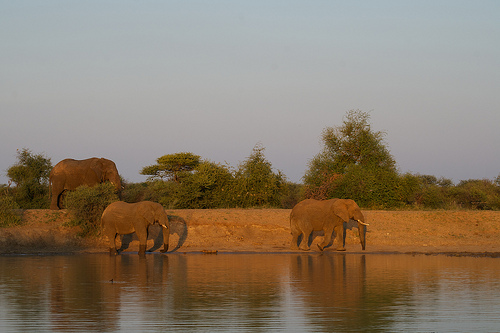Can you describe the environment surrounding the elephants? The surroundings include sparse vegetation, possibly indicative of a savanna or open woodland. There are trees and bushes providing some cover, and the elephants are by a body of water, which is a crucial resource for wildlife in such an environment. What kind of trees are those, do you think? While specific identification would be difficult without clearer detail, they resemble acacia trees, which are common in African savannas and known for their umbrella-shaped canopies. 